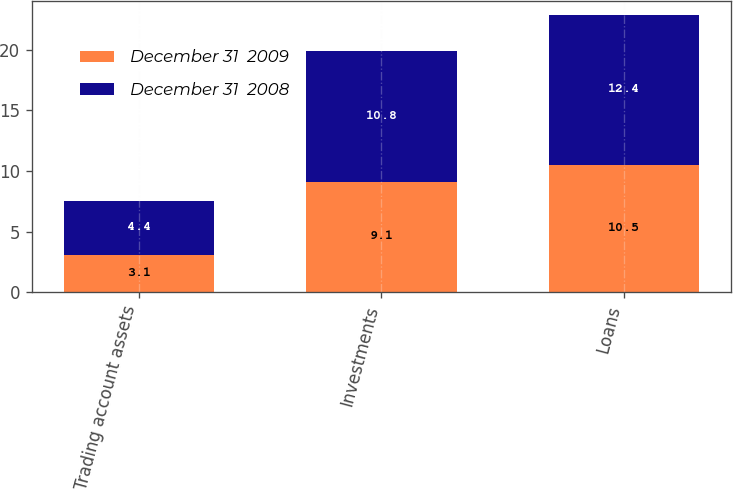<chart> <loc_0><loc_0><loc_500><loc_500><stacked_bar_chart><ecel><fcel>Trading account assets<fcel>Investments<fcel>Loans<nl><fcel>December 31  2009<fcel>3.1<fcel>9.1<fcel>10.5<nl><fcel>December 31  2008<fcel>4.4<fcel>10.8<fcel>12.4<nl></chart> 